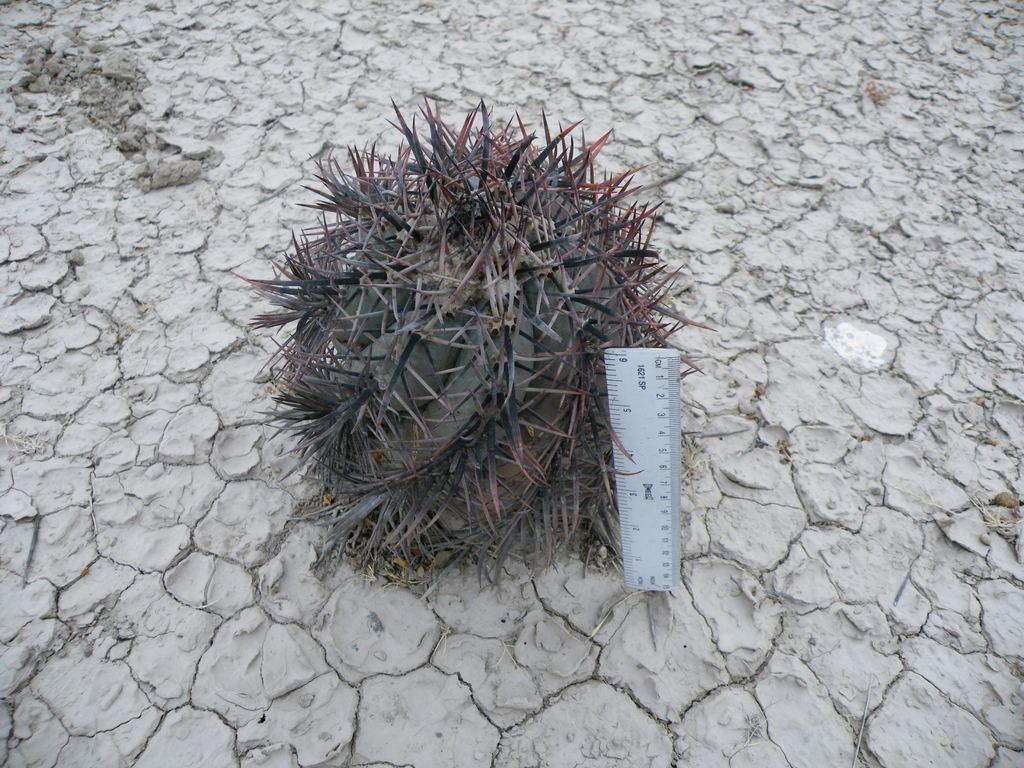What is the main subject in the center of the image? There is a cactus in the center of the image. What else can be seen on the ground in the image? There is a scale on the ground in the image. What type of eggnog is being weighed on the scale in the image? There is no eggnog present in the image; it only features a cactus and a scale on the ground. 